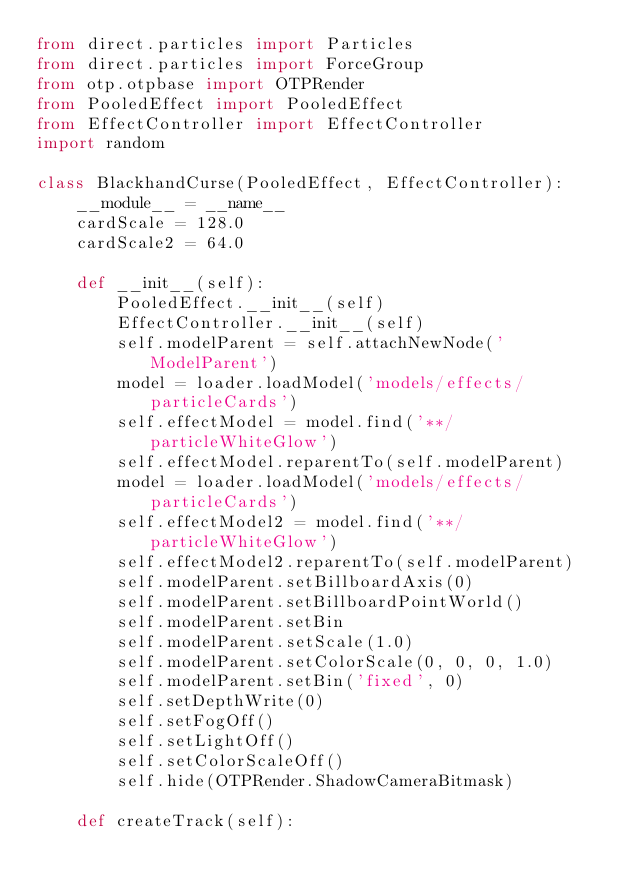Convert code to text. <code><loc_0><loc_0><loc_500><loc_500><_Python_>from direct.particles import Particles
from direct.particles import ForceGroup
from otp.otpbase import OTPRender
from PooledEffect import PooledEffect
from EffectController import EffectController
import random

class BlackhandCurse(PooledEffect, EffectController):
    __module__ = __name__
    cardScale = 128.0
    cardScale2 = 64.0

    def __init__(self):
        PooledEffect.__init__(self)
        EffectController.__init__(self)
        self.modelParent = self.attachNewNode('ModelParent')
        model = loader.loadModel('models/effects/particleCards')
        self.effectModel = model.find('**/particleWhiteGlow')
        self.effectModel.reparentTo(self.modelParent)
        model = loader.loadModel('models/effects/particleCards')
        self.effectModel2 = model.find('**/particleWhiteGlow')
        self.effectModel2.reparentTo(self.modelParent)
        self.modelParent.setBillboardAxis(0)
        self.modelParent.setBillboardPointWorld()
        self.modelParent.setBin
        self.modelParent.setScale(1.0)
        self.modelParent.setColorScale(0, 0, 0, 1.0)
        self.modelParent.setBin('fixed', 0)
        self.setDepthWrite(0)
        self.setFogOff()
        self.setLightOff()
        self.setColorScaleOff()
        self.hide(OTPRender.ShadowCameraBitmask)

    def createTrack(self):</code> 